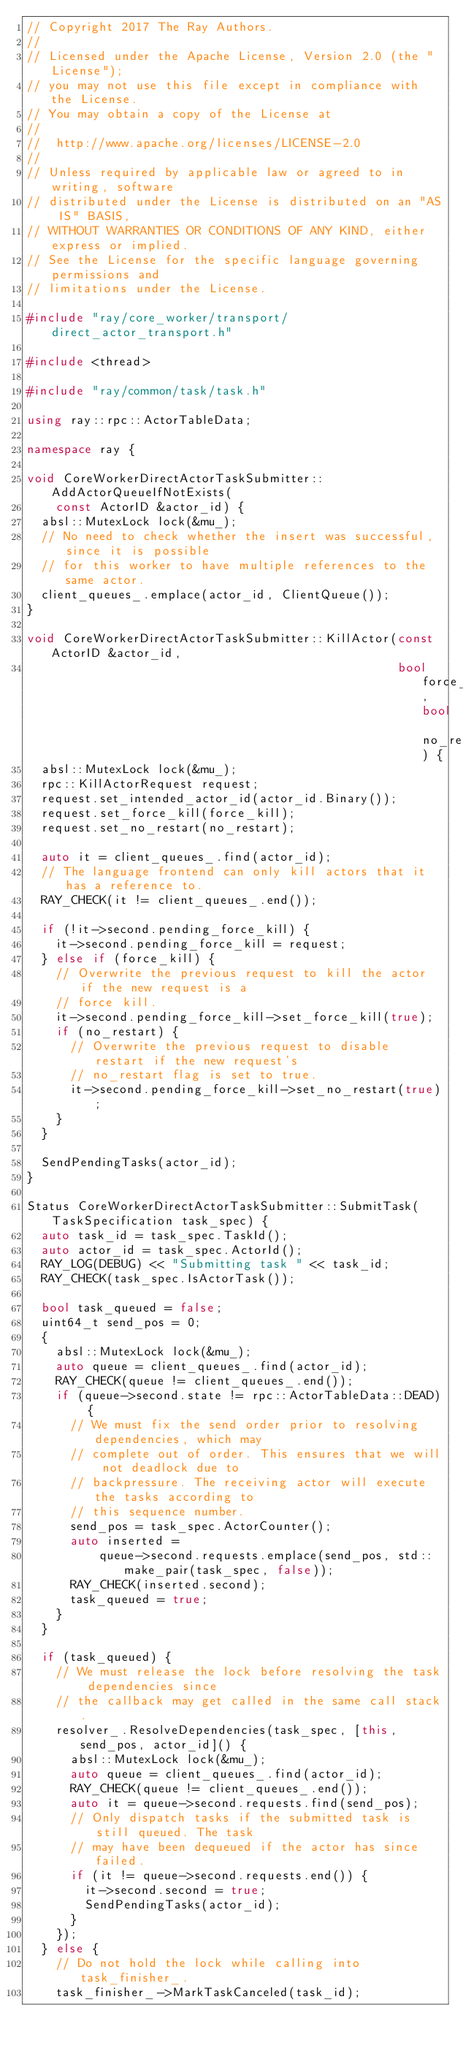Convert code to text. <code><loc_0><loc_0><loc_500><loc_500><_C++_>// Copyright 2017 The Ray Authors.
//
// Licensed under the Apache License, Version 2.0 (the "License");
// you may not use this file except in compliance with the License.
// You may obtain a copy of the License at
//
//  http://www.apache.org/licenses/LICENSE-2.0
//
// Unless required by applicable law or agreed to in writing, software
// distributed under the License is distributed on an "AS IS" BASIS,
// WITHOUT WARRANTIES OR CONDITIONS OF ANY KIND, either express or implied.
// See the License for the specific language governing permissions and
// limitations under the License.

#include "ray/core_worker/transport/direct_actor_transport.h"

#include <thread>

#include "ray/common/task/task.h"

using ray::rpc::ActorTableData;

namespace ray {

void CoreWorkerDirectActorTaskSubmitter::AddActorQueueIfNotExists(
    const ActorID &actor_id) {
  absl::MutexLock lock(&mu_);
  // No need to check whether the insert was successful, since it is possible
  // for this worker to have multiple references to the same actor.
  client_queues_.emplace(actor_id, ClientQueue());
}

void CoreWorkerDirectActorTaskSubmitter::KillActor(const ActorID &actor_id,
                                                   bool force_kill, bool no_restart) {
  absl::MutexLock lock(&mu_);
  rpc::KillActorRequest request;
  request.set_intended_actor_id(actor_id.Binary());
  request.set_force_kill(force_kill);
  request.set_no_restart(no_restart);

  auto it = client_queues_.find(actor_id);
  // The language frontend can only kill actors that it has a reference to.
  RAY_CHECK(it != client_queues_.end());

  if (!it->second.pending_force_kill) {
    it->second.pending_force_kill = request;
  } else if (force_kill) {
    // Overwrite the previous request to kill the actor if the new request is a
    // force kill.
    it->second.pending_force_kill->set_force_kill(true);
    if (no_restart) {
      // Overwrite the previous request to disable restart if the new request's
      // no_restart flag is set to true.
      it->second.pending_force_kill->set_no_restart(true);
    }
  }

  SendPendingTasks(actor_id);
}

Status CoreWorkerDirectActorTaskSubmitter::SubmitTask(TaskSpecification task_spec) {
  auto task_id = task_spec.TaskId();
  auto actor_id = task_spec.ActorId();
  RAY_LOG(DEBUG) << "Submitting task " << task_id;
  RAY_CHECK(task_spec.IsActorTask());

  bool task_queued = false;
  uint64_t send_pos = 0;
  {
    absl::MutexLock lock(&mu_);
    auto queue = client_queues_.find(actor_id);
    RAY_CHECK(queue != client_queues_.end());
    if (queue->second.state != rpc::ActorTableData::DEAD) {
      // We must fix the send order prior to resolving dependencies, which may
      // complete out of order. This ensures that we will not deadlock due to
      // backpressure. The receiving actor will execute the tasks according to
      // this sequence number.
      send_pos = task_spec.ActorCounter();
      auto inserted =
          queue->second.requests.emplace(send_pos, std::make_pair(task_spec, false));
      RAY_CHECK(inserted.second);
      task_queued = true;
    }
  }

  if (task_queued) {
    // We must release the lock before resolving the task dependencies since
    // the callback may get called in the same call stack.
    resolver_.ResolveDependencies(task_spec, [this, send_pos, actor_id]() {
      absl::MutexLock lock(&mu_);
      auto queue = client_queues_.find(actor_id);
      RAY_CHECK(queue != client_queues_.end());
      auto it = queue->second.requests.find(send_pos);
      // Only dispatch tasks if the submitted task is still queued. The task
      // may have been dequeued if the actor has since failed.
      if (it != queue->second.requests.end()) {
        it->second.second = true;
        SendPendingTasks(actor_id);
      }
    });
  } else {
    // Do not hold the lock while calling into task_finisher_.
    task_finisher_->MarkTaskCanceled(task_id);</code> 